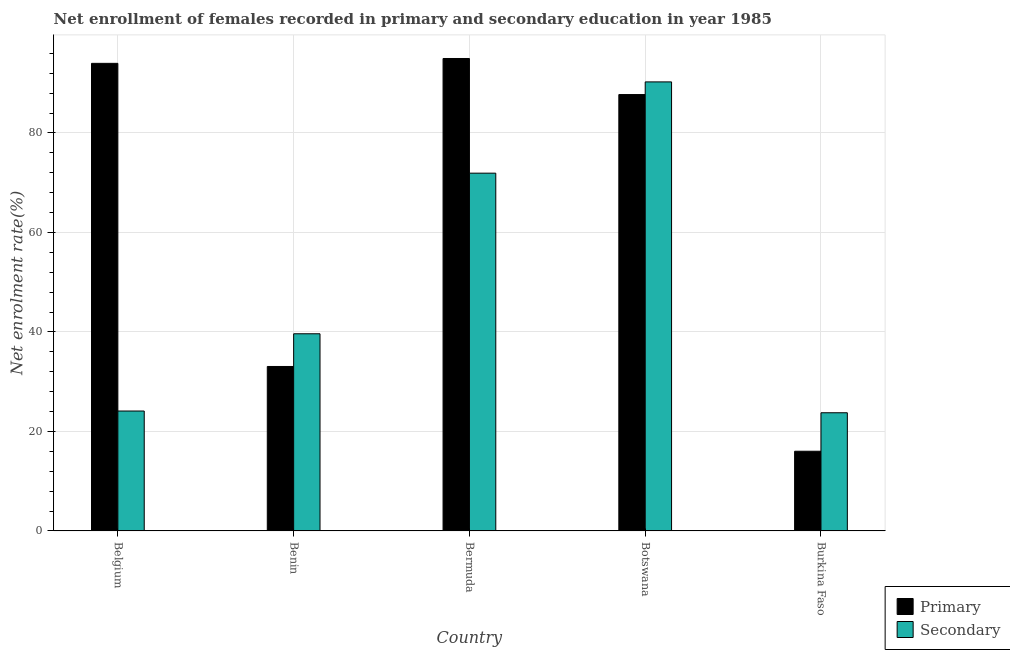How many different coloured bars are there?
Ensure brevity in your answer.  2. How many groups of bars are there?
Your answer should be compact. 5. Are the number of bars per tick equal to the number of legend labels?
Make the answer very short. Yes. Are the number of bars on each tick of the X-axis equal?
Ensure brevity in your answer.  Yes. How many bars are there on the 3rd tick from the left?
Provide a short and direct response. 2. How many bars are there on the 1st tick from the right?
Provide a succinct answer. 2. What is the label of the 4th group of bars from the left?
Offer a terse response. Botswana. In how many cases, is the number of bars for a given country not equal to the number of legend labels?
Your response must be concise. 0. What is the enrollment rate in primary education in Bermuda?
Offer a very short reply. 94.97. Across all countries, what is the maximum enrollment rate in primary education?
Make the answer very short. 94.97. Across all countries, what is the minimum enrollment rate in secondary education?
Give a very brief answer. 23.76. In which country was the enrollment rate in primary education maximum?
Your response must be concise. Bermuda. In which country was the enrollment rate in secondary education minimum?
Provide a succinct answer. Burkina Faso. What is the total enrollment rate in primary education in the graph?
Ensure brevity in your answer.  325.77. What is the difference between the enrollment rate in secondary education in Belgium and that in Bermuda?
Your answer should be compact. -47.82. What is the difference between the enrollment rate in primary education in Bermuda and the enrollment rate in secondary education in Botswana?
Ensure brevity in your answer.  4.7. What is the average enrollment rate in primary education per country?
Make the answer very short. 65.15. What is the difference between the enrollment rate in primary education and enrollment rate in secondary education in Benin?
Your answer should be compact. -6.58. In how many countries, is the enrollment rate in primary education greater than 36 %?
Your response must be concise. 3. What is the ratio of the enrollment rate in secondary education in Benin to that in Burkina Faso?
Provide a succinct answer. 1.67. Is the enrollment rate in primary education in Benin less than that in Bermuda?
Provide a short and direct response. Yes. Is the difference between the enrollment rate in secondary education in Benin and Bermuda greater than the difference between the enrollment rate in primary education in Benin and Bermuda?
Your answer should be compact. Yes. What is the difference between the highest and the second highest enrollment rate in primary education?
Ensure brevity in your answer.  0.98. What is the difference between the highest and the lowest enrollment rate in primary education?
Keep it short and to the point. 78.95. Is the sum of the enrollment rate in secondary education in Belgium and Benin greater than the maximum enrollment rate in primary education across all countries?
Provide a succinct answer. No. What does the 2nd bar from the left in Belgium represents?
Make the answer very short. Secondary. What does the 2nd bar from the right in Belgium represents?
Offer a terse response. Primary. Are all the bars in the graph horizontal?
Your answer should be very brief. No. How many countries are there in the graph?
Your response must be concise. 5. What is the difference between two consecutive major ticks on the Y-axis?
Give a very brief answer. 20. Does the graph contain grids?
Provide a short and direct response. Yes. What is the title of the graph?
Give a very brief answer. Net enrollment of females recorded in primary and secondary education in year 1985. What is the label or title of the Y-axis?
Make the answer very short. Net enrolment rate(%). What is the Net enrolment rate(%) of Primary in Belgium?
Your response must be concise. 94. What is the Net enrolment rate(%) in Secondary in Belgium?
Provide a succinct answer. 24.11. What is the Net enrolment rate(%) of Primary in Benin?
Give a very brief answer. 33.06. What is the Net enrolment rate(%) in Secondary in Benin?
Give a very brief answer. 39.64. What is the Net enrolment rate(%) in Primary in Bermuda?
Provide a succinct answer. 94.97. What is the Net enrolment rate(%) of Secondary in Bermuda?
Give a very brief answer. 71.92. What is the Net enrolment rate(%) in Primary in Botswana?
Provide a succinct answer. 87.72. What is the Net enrolment rate(%) of Secondary in Botswana?
Provide a succinct answer. 90.27. What is the Net enrolment rate(%) of Primary in Burkina Faso?
Your response must be concise. 16.02. What is the Net enrolment rate(%) in Secondary in Burkina Faso?
Your response must be concise. 23.76. Across all countries, what is the maximum Net enrolment rate(%) in Primary?
Your response must be concise. 94.97. Across all countries, what is the maximum Net enrolment rate(%) in Secondary?
Make the answer very short. 90.27. Across all countries, what is the minimum Net enrolment rate(%) of Primary?
Offer a terse response. 16.02. Across all countries, what is the minimum Net enrolment rate(%) in Secondary?
Offer a terse response. 23.76. What is the total Net enrolment rate(%) of Primary in the graph?
Make the answer very short. 325.77. What is the total Net enrolment rate(%) in Secondary in the graph?
Keep it short and to the point. 249.69. What is the difference between the Net enrolment rate(%) of Primary in Belgium and that in Benin?
Your answer should be very brief. 60.94. What is the difference between the Net enrolment rate(%) of Secondary in Belgium and that in Benin?
Your answer should be compact. -15.53. What is the difference between the Net enrolment rate(%) of Primary in Belgium and that in Bermuda?
Your answer should be compact. -0.98. What is the difference between the Net enrolment rate(%) of Secondary in Belgium and that in Bermuda?
Provide a succinct answer. -47.82. What is the difference between the Net enrolment rate(%) in Primary in Belgium and that in Botswana?
Give a very brief answer. 6.27. What is the difference between the Net enrolment rate(%) in Secondary in Belgium and that in Botswana?
Give a very brief answer. -66.16. What is the difference between the Net enrolment rate(%) in Primary in Belgium and that in Burkina Faso?
Ensure brevity in your answer.  77.98. What is the difference between the Net enrolment rate(%) of Secondary in Belgium and that in Burkina Faso?
Keep it short and to the point. 0.35. What is the difference between the Net enrolment rate(%) of Primary in Benin and that in Bermuda?
Offer a very short reply. -61.91. What is the difference between the Net enrolment rate(%) in Secondary in Benin and that in Bermuda?
Your response must be concise. -32.29. What is the difference between the Net enrolment rate(%) in Primary in Benin and that in Botswana?
Your answer should be compact. -54.66. What is the difference between the Net enrolment rate(%) in Secondary in Benin and that in Botswana?
Your response must be concise. -50.63. What is the difference between the Net enrolment rate(%) of Primary in Benin and that in Burkina Faso?
Provide a succinct answer. 17.04. What is the difference between the Net enrolment rate(%) in Secondary in Benin and that in Burkina Faso?
Your answer should be very brief. 15.88. What is the difference between the Net enrolment rate(%) in Primary in Bermuda and that in Botswana?
Your response must be concise. 7.25. What is the difference between the Net enrolment rate(%) of Secondary in Bermuda and that in Botswana?
Your response must be concise. -18.35. What is the difference between the Net enrolment rate(%) in Primary in Bermuda and that in Burkina Faso?
Offer a very short reply. 78.95. What is the difference between the Net enrolment rate(%) of Secondary in Bermuda and that in Burkina Faso?
Your answer should be compact. 48.16. What is the difference between the Net enrolment rate(%) in Primary in Botswana and that in Burkina Faso?
Provide a succinct answer. 71.7. What is the difference between the Net enrolment rate(%) in Secondary in Botswana and that in Burkina Faso?
Your response must be concise. 66.51. What is the difference between the Net enrolment rate(%) in Primary in Belgium and the Net enrolment rate(%) in Secondary in Benin?
Provide a short and direct response. 54.36. What is the difference between the Net enrolment rate(%) in Primary in Belgium and the Net enrolment rate(%) in Secondary in Bermuda?
Provide a succinct answer. 22.07. What is the difference between the Net enrolment rate(%) of Primary in Belgium and the Net enrolment rate(%) of Secondary in Botswana?
Offer a terse response. 3.73. What is the difference between the Net enrolment rate(%) in Primary in Belgium and the Net enrolment rate(%) in Secondary in Burkina Faso?
Your answer should be compact. 70.24. What is the difference between the Net enrolment rate(%) in Primary in Benin and the Net enrolment rate(%) in Secondary in Bermuda?
Give a very brief answer. -38.86. What is the difference between the Net enrolment rate(%) in Primary in Benin and the Net enrolment rate(%) in Secondary in Botswana?
Your answer should be very brief. -57.21. What is the difference between the Net enrolment rate(%) of Primary in Benin and the Net enrolment rate(%) of Secondary in Burkina Faso?
Offer a very short reply. 9.3. What is the difference between the Net enrolment rate(%) of Primary in Bermuda and the Net enrolment rate(%) of Secondary in Botswana?
Keep it short and to the point. 4.71. What is the difference between the Net enrolment rate(%) of Primary in Bermuda and the Net enrolment rate(%) of Secondary in Burkina Faso?
Your answer should be very brief. 71.21. What is the difference between the Net enrolment rate(%) in Primary in Botswana and the Net enrolment rate(%) in Secondary in Burkina Faso?
Your answer should be compact. 63.97. What is the average Net enrolment rate(%) of Primary per country?
Give a very brief answer. 65.15. What is the average Net enrolment rate(%) in Secondary per country?
Provide a succinct answer. 49.94. What is the difference between the Net enrolment rate(%) of Primary and Net enrolment rate(%) of Secondary in Belgium?
Give a very brief answer. 69.89. What is the difference between the Net enrolment rate(%) in Primary and Net enrolment rate(%) in Secondary in Benin?
Give a very brief answer. -6.58. What is the difference between the Net enrolment rate(%) of Primary and Net enrolment rate(%) of Secondary in Bermuda?
Offer a very short reply. 23.05. What is the difference between the Net enrolment rate(%) of Primary and Net enrolment rate(%) of Secondary in Botswana?
Keep it short and to the point. -2.54. What is the difference between the Net enrolment rate(%) of Primary and Net enrolment rate(%) of Secondary in Burkina Faso?
Ensure brevity in your answer.  -7.74. What is the ratio of the Net enrolment rate(%) in Primary in Belgium to that in Benin?
Your answer should be very brief. 2.84. What is the ratio of the Net enrolment rate(%) in Secondary in Belgium to that in Benin?
Keep it short and to the point. 0.61. What is the ratio of the Net enrolment rate(%) in Secondary in Belgium to that in Bermuda?
Keep it short and to the point. 0.34. What is the ratio of the Net enrolment rate(%) in Primary in Belgium to that in Botswana?
Your answer should be very brief. 1.07. What is the ratio of the Net enrolment rate(%) of Secondary in Belgium to that in Botswana?
Offer a terse response. 0.27. What is the ratio of the Net enrolment rate(%) in Primary in Belgium to that in Burkina Faso?
Ensure brevity in your answer.  5.87. What is the ratio of the Net enrolment rate(%) of Secondary in Belgium to that in Burkina Faso?
Your answer should be very brief. 1.01. What is the ratio of the Net enrolment rate(%) in Primary in Benin to that in Bermuda?
Provide a short and direct response. 0.35. What is the ratio of the Net enrolment rate(%) in Secondary in Benin to that in Bermuda?
Your answer should be compact. 0.55. What is the ratio of the Net enrolment rate(%) in Primary in Benin to that in Botswana?
Your response must be concise. 0.38. What is the ratio of the Net enrolment rate(%) of Secondary in Benin to that in Botswana?
Offer a terse response. 0.44. What is the ratio of the Net enrolment rate(%) of Primary in Benin to that in Burkina Faso?
Your answer should be compact. 2.06. What is the ratio of the Net enrolment rate(%) of Secondary in Benin to that in Burkina Faso?
Your answer should be very brief. 1.67. What is the ratio of the Net enrolment rate(%) of Primary in Bermuda to that in Botswana?
Keep it short and to the point. 1.08. What is the ratio of the Net enrolment rate(%) in Secondary in Bermuda to that in Botswana?
Your response must be concise. 0.8. What is the ratio of the Net enrolment rate(%) in Primary in Bermuda to that in Burkina Faso?
Provide a short and direct response. 5.93. What is the ratio of the Net enrolment rate(%) in Secondary in Bermuda to that in Burkina Faso?
Offer a terse response. 3.03. What is the ratio of the Net enrolment rate(%) of Primary in Botswana to that in Burkina Faso?
Provide a short and direct response. 5.48. What is the ratio of the Net enrolment rate(%) of Secondary in Botswana to that in Burkina Faso?
Keep it short and to the point. 3.8. What is the difference between the highest and the second highest Net enrolment rate(%) of Primary?
Make the answer very short. 0.98. What is the difference between the highest and the second highest Net enrolment rate(%) of Secondary?
Offer a very short reply. 18.35. What is the difference between the highest and the lowest Net enrolment rate(%) in Primary?
Your answer should be very brief. 78.95. What is the difference between the highest and the lowest Net enrolment rate(%) of Secondary?
Your answer should be very brief. 66.51. 